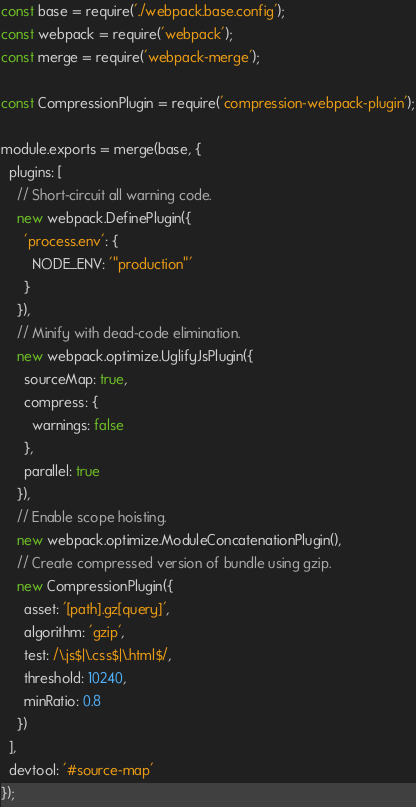<code> <loc_0><loc_0><loc_500><loc_500><_JavaScript_>const base = require('./webpack.base.config');
const webpack = require('webpack');
const merge = require('webpack-merge');

const CompressionPlugin = require('compression-webpack-plugin');

module.exports = merge(base, {
  plugins: [
    // Short-circuit all warning code.
    new webpack.DefinePlugin({
      'process.env': {
        NODE_ENV: '"production"'
      }
    }),
    // Minify with dead-code elimination.
    new webpack.optimize.UglifyJsPlugin({
      sourceMap: true,
      compress: {
        warnings: false
      },
      parallel: true
    }),
    // Enable scope hoisting.
    new webpack.optimize.ModuleConcatenationPlugin(),
    // Create compressed version of bundle using gzip.
    new CompressionPlugin({
      asset: '[path].gz[query]',
      algorithm: 'gzip',
      test: /\.js$|\.css$|\.html$/,
      threshold: 10240,
      minRatio: 0.8
    })
  ],
  devtool: '#source-map'
});
</code> 